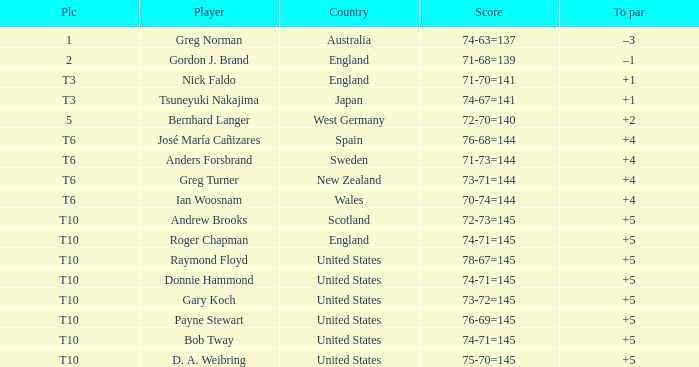Parse the table in full. {'header': ['Plc', 'Player', 'Country', 'Score', 'To par'], 'rows': [['1', 'Greg Norman', 'Australia', '74-63=137', '–3'], ['2', 'Gordon J. Brand', 'England', '71-68=139', '–1'], ['T3', 'Nick Faldo', 'England', '71-70=141', '+1'], ['T3', 'Tsuneyuki Nakajima', 'Japan', '74-67=141', '+1'], ['5', 'Bernhard Langer', 'West Germany', '72-70=140', '+2'], ['T6', 'José María Cañizares', 'Spain', '76-68=144', '+4'], ['T6', 'Anders Forsbrand', 'Sweden', '71-73=144', '+4'], ['T6', 'Greg Turner', 'New Zealand', '73-71=144', '+4'], ['T6', 'Ian Woosnam', 'Wales', '70-74=144', '+4'], ['T10', 'Andrew Brooks', 'Scotland', '72-73=145', '+5'], ['T10', 'Roger Chapman', 'England', '74-71=145', '+5'], ['T10', 'Raymond Floyd', 'United States', '78-67=145', '+5'], ['T10', 'Donnie Hammond', 'United States', '74-71=145', '+5'], ['T10', 'Gary Koch', 'United States', '73-72=145', '+5'], ['T10', 'Payne Stewart', 'United States', '76-69=145', '+5'], ['T10', 'Bob Tway', 'United States', '74-71=145', '+5'], ['T10', 'D. A. Weibring', 'United States', '75-70=145', '+5']]} What did United States place when the player was Raymond Floyd? T10. 